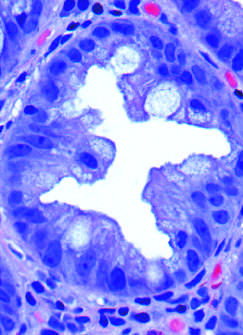re glands cut in cross-section?
Answer the question using a single word or phrase. Yes 